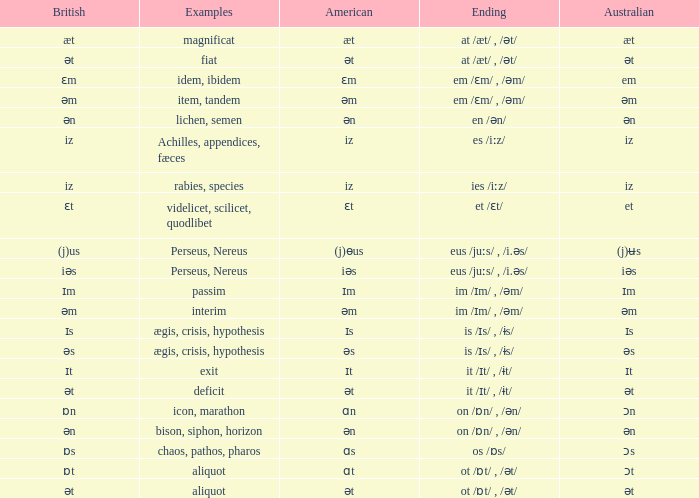Which Examples has Australian of əm? Item, tandem, interim. 